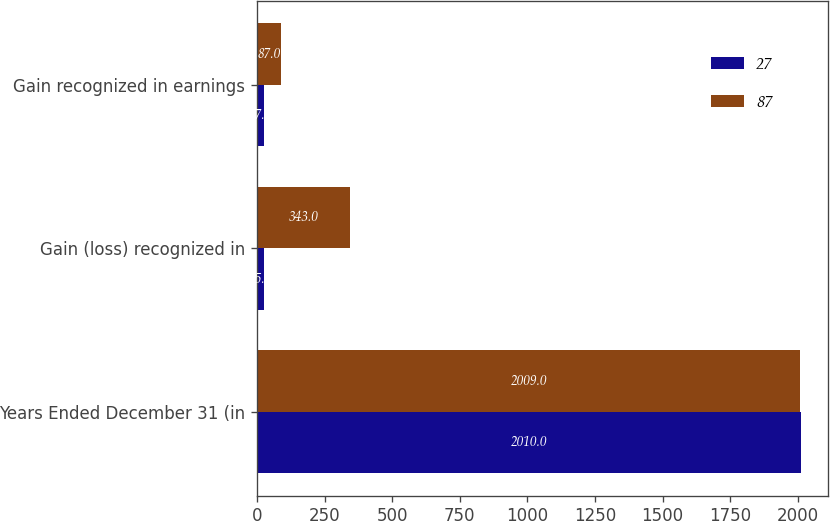Convert chart to OTSL. <chart><loc_0><loc_0><loc_500><loc_500><stacked_bar_chart><ecel><fcel>Years Ended December 31 (in<fcel>Gain (loss) recognized in<fcel>Gain recognized in earnings<nl><fcel>27<fcel>2010<fcel>25<fcel>27<nl><fcel>87<fcel>2009<fcel>343<fcel>87<nl></chart> 